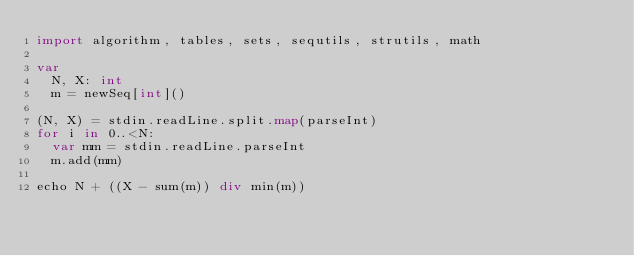Convert code to text. <code><loc_0><loc_0><loc_500><loc_500><_Nim_>import algorithm, tables, sets, sequtils, strutils, math

var
  N, X: int
  m = newSeq[int]()

(N, X) = stdin.readLine.split.map(parseInt)
for i in 0..<N:
  var mm = stdin.readLine.parseInt
  m.add(mm)

echo N + ((X - sum(m)) div min(m))</code> 